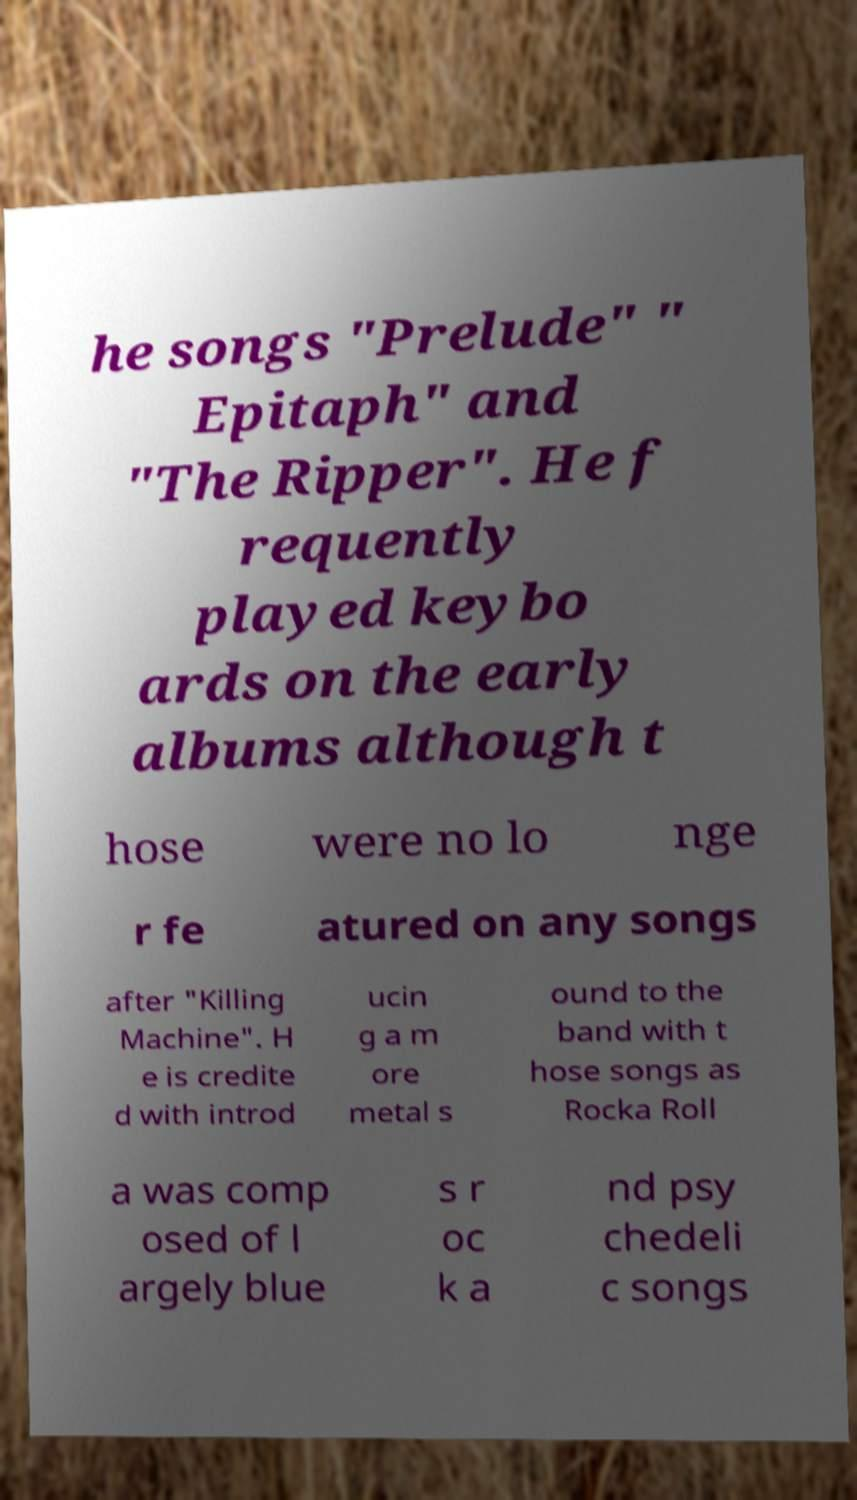I need the written content from this picture converted into text. Can you do that? he songs "Prelude" " Epitaph" and "The Ripper". He f requently played keybo ards on the early albums although t hose were no lo nge r fe atured on any songs after "Killing Machine". H e is credite d with introd ucin g a m ore metal s ound to the band with t hose songs as Rocka Roll a was comp osed of l argely blue s r oc k a nd psy chedeli c songs 